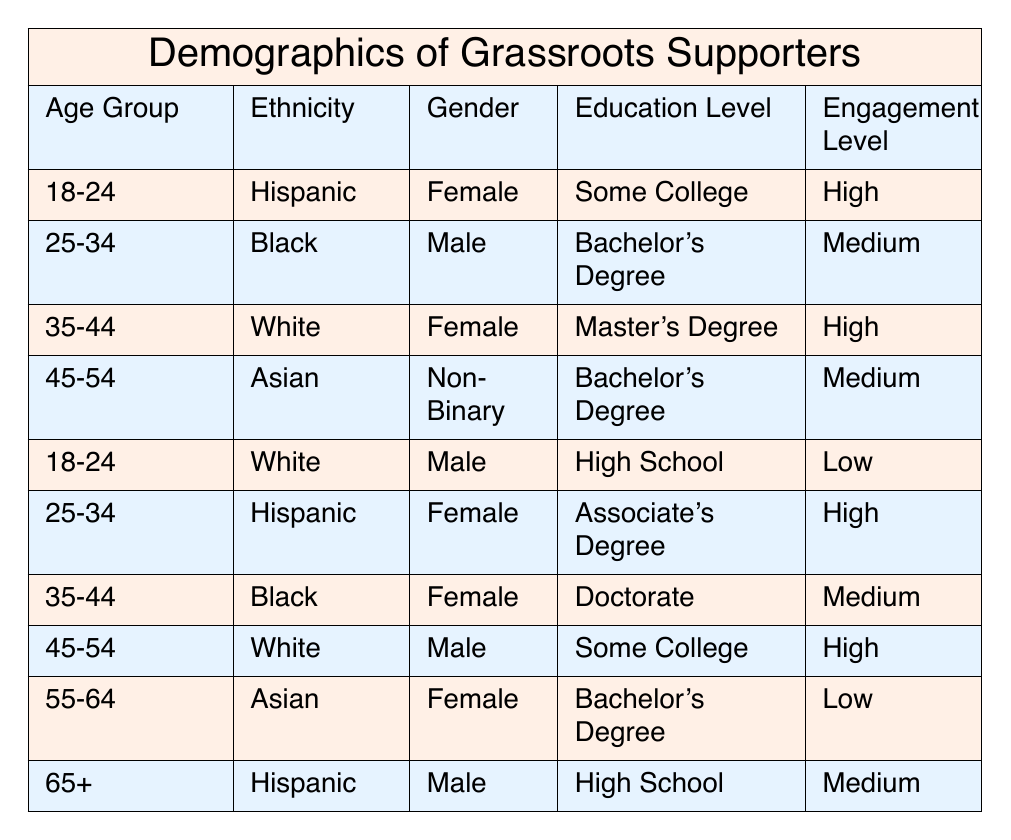What is the engagement level of individuals aged 35-44 who identify as female? There are two individuals aged 35-44 in the table. One identifies as female and has a Master's Degree with a high engagement level, while the other is also female with a Doctorate and has a medium engagement level. Therefore, the engagement level for females in this age group is both high and medium.
Answer: High and medium How many individuals have an education level of Bachelor's Degree? There are three individuals in the table with a Bachelor's Degree, one is aged 25-34 and male, another is aged 45-54 and male, and the third is aged 35-44 and female.
Answer: 3 Is there anyone aged 55-64 with a high engagement level? The only individual aged 55-64 in the table is female with a Bachelor's Degree and a low engagement level, so the answer is no.
Answer: No What is the average engagement level for individuals from the Hispanic ethnicity? There are three individuals who identify as Hispanic, ages 18-24 (high), 25-34 (high), and 65+ (medium). To determine average engagement, we assign numeric values: High (1), Medium (0.5), Low (0). The sum of engagement levels is 1 + 1 + 0.5 = 2.5. The average is 2.5 / 3 ≈ 0.83 or roughly between high and medium.
Answer: Between high and medium Are there more males or females with a low engagement level? In the table, two individuals have a low engagement level: one female aged 55-64 and one male aged 18-24. Since both genders have one individual each, the answer is equal.
Answer: Equal 